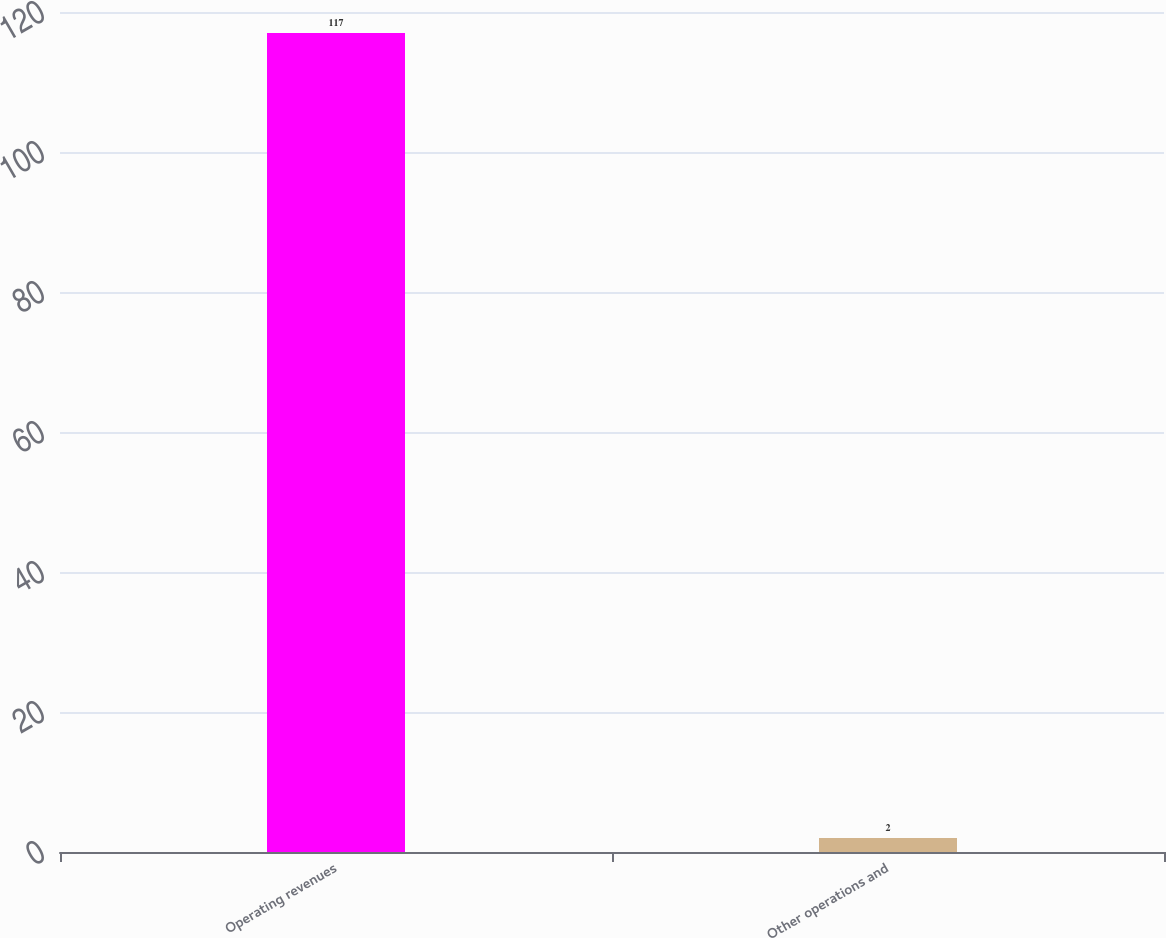Convert chart to OTSL. <chart><loc_0><loc_0><loc_500><loc_500><bar_chart><fcel>Operating revenues<fcel>Other operations and<nl><fcel>117<fcel>2<nl></chart> 